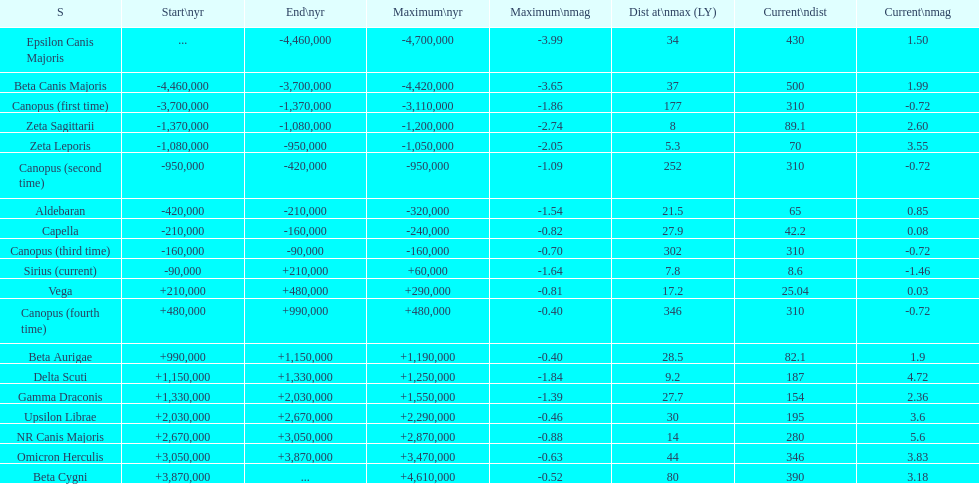Is capella's current magnitude more than vega's current magnitude? Yes. 